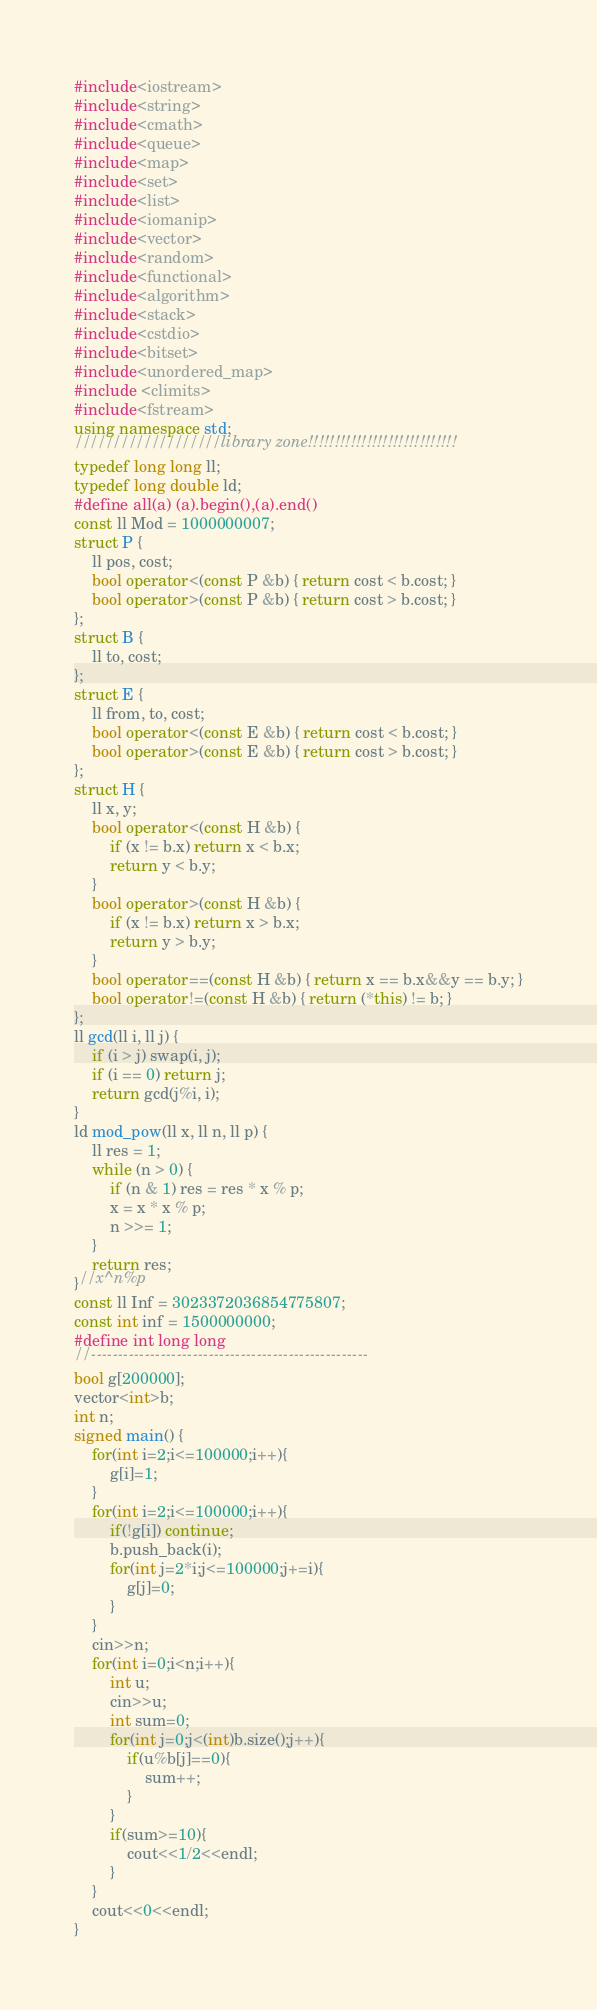Convert code to text. <code><loc_0><loc_0><loc_500><loc_500><_C++_>#include<iostream>
#include<string>
#include<cmath>
#include<queue>
#include<map>
#include<set>
#include<list>
#include<iomanip>
#include<vector>
#include<random>
#include<functional>
#include<algorithm>
#include<stack>
#include<cstdio>
#include<bitset>
#include<unordered_map>
#include <climits>
#include<fstream>
using namespace std;
///////////////////library zone!!!!!!!!!!!!!!!!!!!!!!!!!!!!
typedef long long ll;
typedef long double ld;
#define all(a) (a).begin(),(a).end()
const ll Mod = 1000000007;
struct P {
	ll pos, cost;
	bool operator<(const P &b) { return cost < b.cost; }
	bool operator>(const P &b) { return cost > b.cost; }
};
struct B {
	ll to, cost;
};
struct E {
	ll from, to, cost;
	bool operator<(const E &b) { return cost < b.cost; }
	bool operator>(const E &b) { return cost > b.cost; }
};
struct H {
	ll x, y;
	bool operator<(const H &b) {
		if (x != b.x) return x < b.x;
		return y < b.y;
	}
	bool operator>(const H &b) {
		if (x != b.x) return x > b.x;
		return y > b.y;
	}
	bool operator==(const H &b) { return x == b.x&&y == b.y; }
	bool operator!=(const H &b) { return (*this) != b; }
};
ll gcd(ll i, ll j) {
	if (i > j) swap(i, j);
	if (i == 0) return j;
	return gcd(j%i, i);
}
ld mod_pow(ll x, ll n, ll p) {
	ll res = 1;
	while (n > 0) {
		if (n & 1) res = res * x % p;
		x = x * x % p;
		n >>= 1;
	}
	return res;
}//x^n%p
const ll Inf = 3023372036854775807;
const int inf = 1500000000;
#define int long long
//----------------------------------------------------
bool g[200000];
vector<int>b;
int n;
signed main() {
	for(int i=2;i<=100000;i++){
		g[i]=1;
	}
	for(int i=2;i<=100000;i++){
		if(!g[i]) continue;
		b.push_back(i);
		for(int j=2*i;j<=100000;j+=i){
			g[j]=0;
		}
	}
	cin>>n;
	for(int i=0;i<n;i++){
		int u;
		cin>>u;
		int sum=0;
		for(int j=0;j<(int)b.size();j++){
			if(u%b[j]==0){
				sum++;
			}
		}
		if(sum>=10){
			cout<<1/2<<endl;
		}
	}
	cout<<0<<endl;
}
</code> 